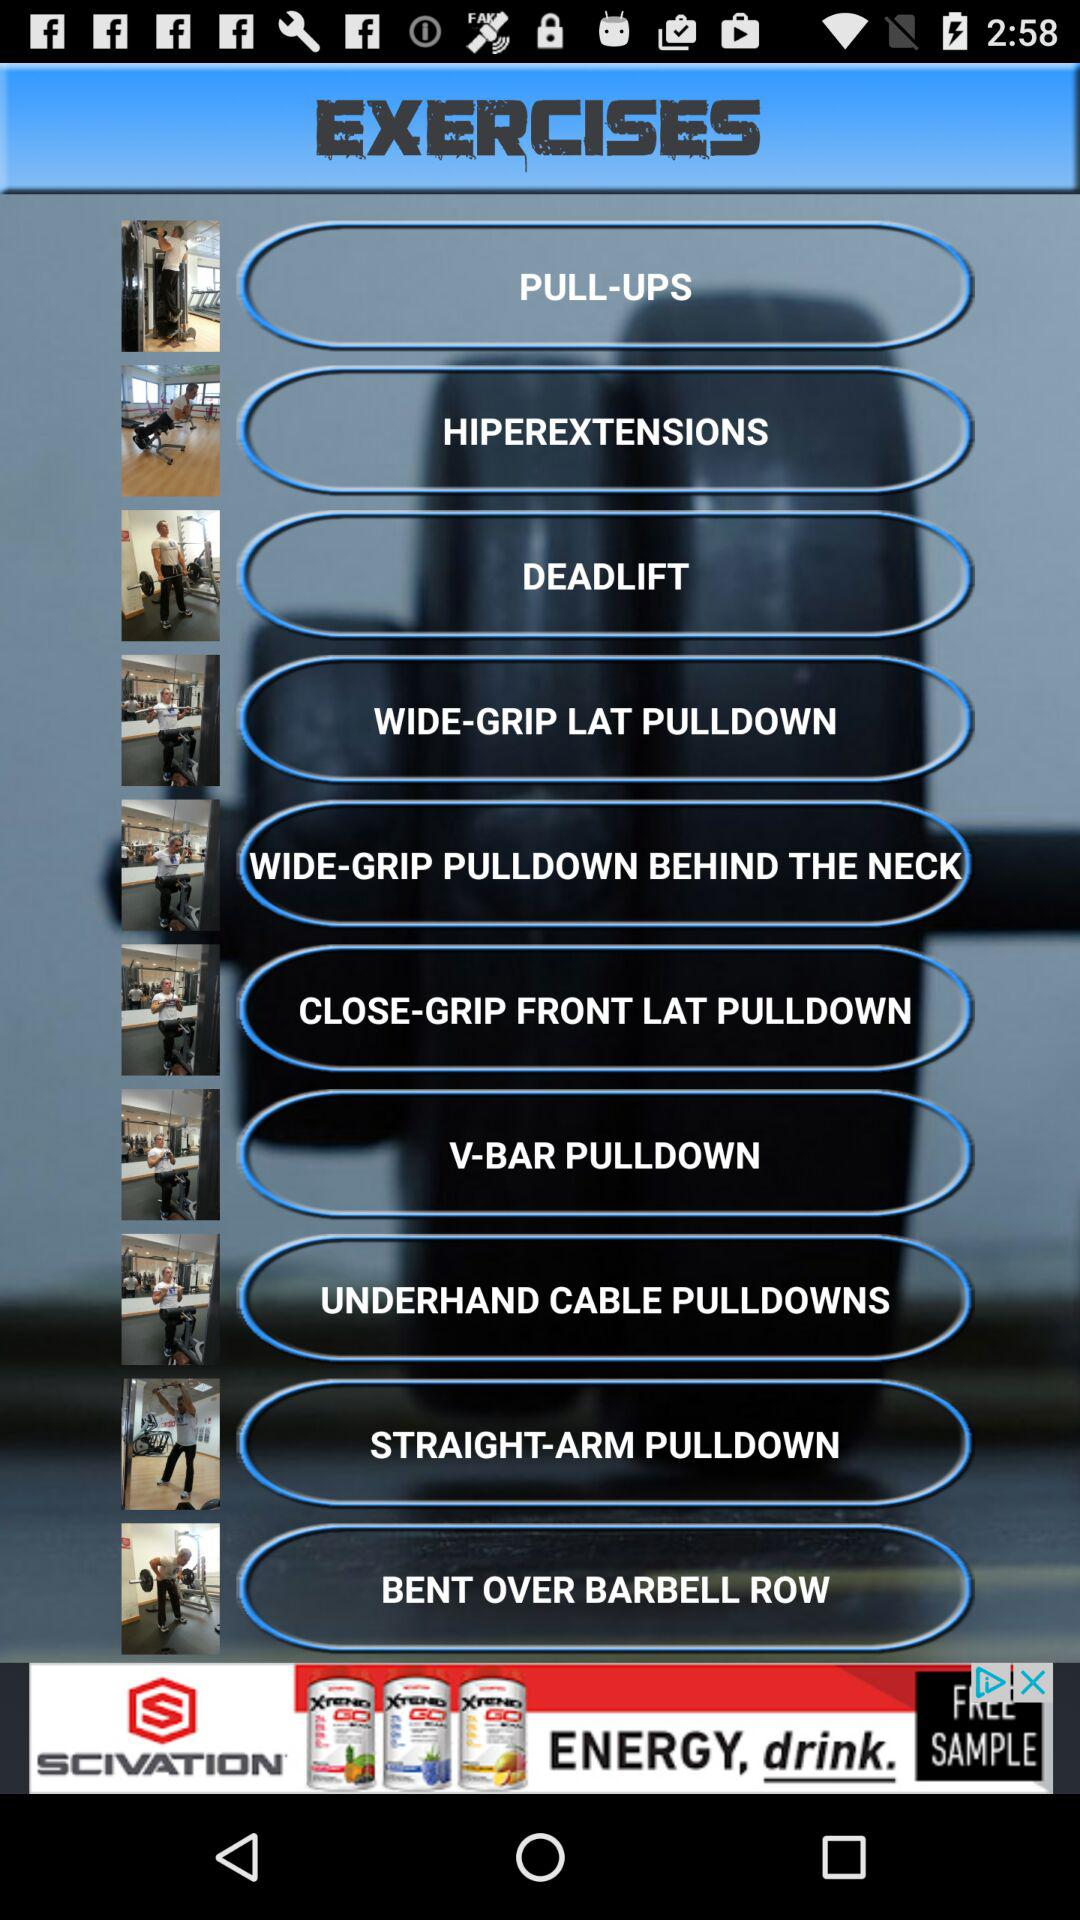Which are the different exercises? The different exercises are "PULL-UPS", "HIPEREXTENSIONS", "DEADLIFT", "WIDE-GRIP LAT PULLDOWN", "WIDE-GRIP PULLDOWN BEHIND THE NECK", "CLOSE-GRIP FRONT LAT PULLDOWN", "V-BAR PULLDOWN", "UNDERHAND CABLE PULLDOWNS", "STRAIGHT-ARM PULLDOWN" and "BENT OVER BARBELL ROW". 